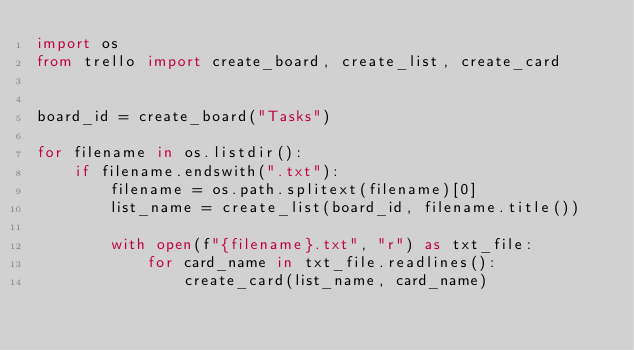<code> <loc_0><loc_0><loc_500><loc_500><_Python_>import os
from trello import create_board, create_list, create_card
 
 
board_id = create_board("Tasks")
 
for filename in os.listdir():
    if filename.endswith(".txt"):
        filename = os.path.splitext(filename)[0]
        list_name = create_list(board_id, filename.title())
 
        with open(f"{filename}.txt", "r") as txt_file:
            for card_name in txt_file.readlines():
                create_card(list_name, card_name)
</code> 